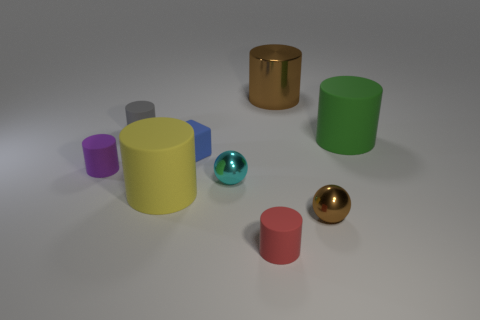Subtract all big green matte cylinders. How many cylinders are left? 5 Add 1 brown shiny cylinders. How many objects exist? 10 Subtract all red cylinders. How many cylinders are left? 5 Subtract all balls. How many objects are left? 7 Add 5 purple matte things. How many purple matte things exist? 6 Subtract 1 brown spheres. How many objects are left? 8 Subtract 3 cylinders. How many cylinders are left? 3 Subtract all purple spheres. Subtract all brown cylinders. How many spheres are left? 2 Subtract all cyan spheres. How many cyan cylinders are left? 0 Subtract all brown shiny cylinders. Subtract all tiny red cylinders. How many objects are left? 7 